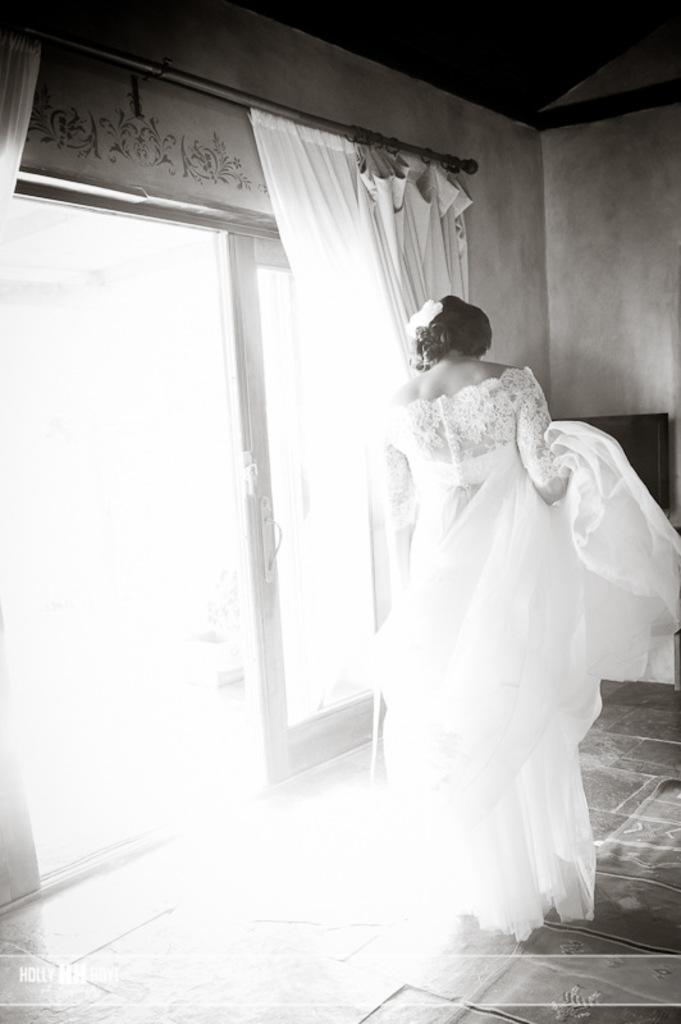How would you summarize this image in a sentence or two? In this picture there is a woman wearing white dress is standing and there is a glass door and curtain beside her. 